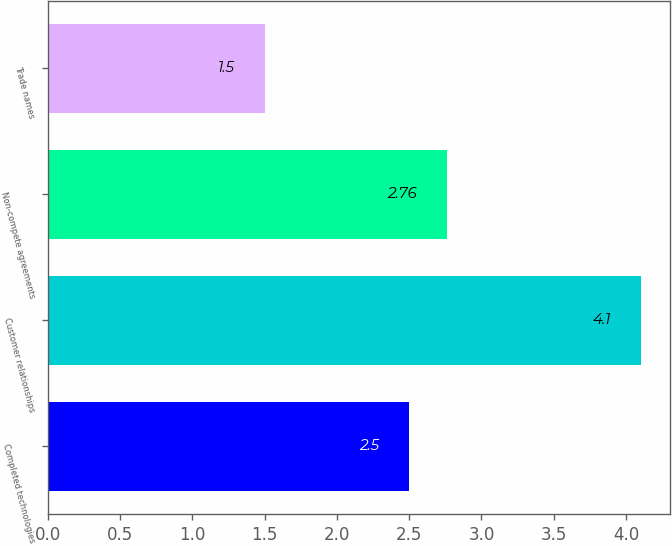Convert chart. <chart><loc_0><loc_0><loc_500><loc_500><bar_chart><fcel>Completed technologies<fcel>Customer relationships<fcel>Non-compete agreements<fcel>Trade names<nl><fcel>2.5<fcel>4.1<fcel>2.76<fcel>1.5<nl></chart> 